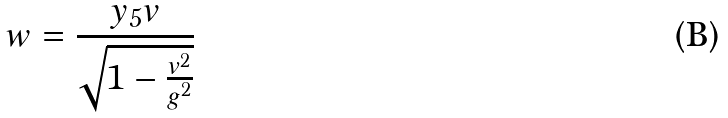Convert formula to latex. <formula><loc_0><loc_0><loc_500><loc_500>w = \frac { y _ { 5 } v } { \sqrt { 1 - \frac { v ^ { 2 } } { g ^ { 2 } } } }</formula> 